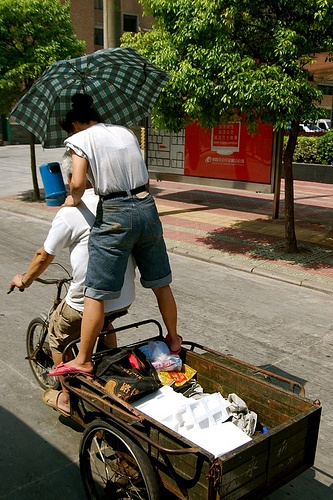Describe the objects in this image and their specific colors. I can see people in olive, black, lightgray, darkgray, and gray tones, people in olive, black, white, gray, and darkgray tones, umbrella in olive, black, gray, darkgreen, and teal tones, bicycle in olive, black, darkgray, darkgreen, and gray tones, and car in olive, black, gray, darkgray, and lightgray tones in this image. 